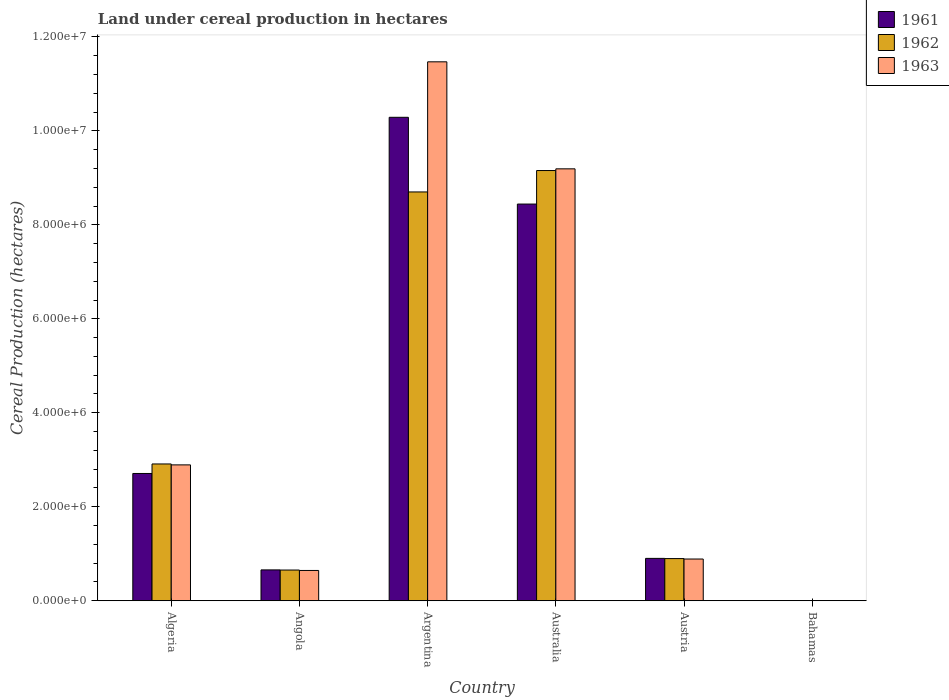How many groups of bars are there?
Offer a terse response. 6. How many bars are there on the 4th tick from the left?
Offer a very short reply. 3. What is the label of the 2nd group of bars from the left?
Ensure brevity in your answer.  Angola. In how many cases, is the number of bars for a given country not equal to the number of legend labels?
Give a very brief answer. 0. What is the land under cereal production in 1962 in Algeria?
Make the answer very short. 2.91e+06. Across all countries, what is the maximum land under cereal production in 1961?
Offer a very short reply. 1.03e+07. Across all countries, what is the minimum land under cereal production in 1963?
Provide a succinct answer. 240. In which country was the land under cereal production in 1961 minimum?
Your response must be concise. Bahamas. What is the total land under cereal production in 1963 in the graph?
Ensure brevity in your answer.  2.51e+07. What is the difference between the land under cereal production in 1963 in Angola and that in Argentina?
Ensure brevity in your answer.  -1.08e+07. What is the difference between the land under cereal production in 1961 in Algeria and the land under cereal production in 1962 in Argentina?
Make the answer very short. -5.99e+06. What is the average land under cereal production in 1961 per country?
Ensure brevity in your answer.  3.83e+06. What is the difference between the land under cereal production of/in 1962 and land under cereal production of/in 1961 in Argentina?
Your response must be concise. -1.59e+06. What is the ratio of the land under cereal production in 1962 in Argentina to that in Australia?
Offer a terse response. 0.95. What is the difference between the highest and the second highest land under cereal production in 1963?
Your response must be concise. 6.30e+06. What is the difference between the highest and the lowest land under cereal production in 1962?
Your response must be concise. 9.15e+06. Is the sum of the land under cereal production in 1962 in Algeria and Argentina greater than the maximum land under cereal production in 1963 across all countries?
Offer a very short reply. Yes. What does the 3rd bar from the left in Algeria represents?
Offer a very short reply. 1963. How many bars are there?
Give a very brief answer. 18. How many countries are there in the graph?
Give a very brief answer. 6. Does the graph contain grids?
Give a very brief answer. No. Where does the legend appear in the graph?
Ensure brevity in your answer.  Top right. How many legend labels are there?
Your answer should be compact. 3. What is the title of the graph?
Your response must be concise. Land under cereal production in hectares. What is the label or title of the X-axis?
Offer a very short reply. Country. What is the label or title of the Y-axis?
Your answer should be very brief. Cereal Production (hectares). What is the Cereal Production (hectares) in 1961 in Algeria?
Keep it short and to the point. 2.71e+06. What is the Cereal Production (hectares) of 1962 in Algeria?
Keep it short and to the point. 2.91e+06. What is the Cereal Production (hectares) in 1963 in Algeria?
Your response must be concise. 2.89e+06. What is the Cereal Production (hectares) in 1961 in Angola?
Your answer should be very brief. 6.57e+05. What is the Cereal Production (hectares) in 1962 in Angola?
Keep it short and to the point. 6.54e+05. What is the Cereal Production (hectares) of 1963 in Angola?
Your response must be concise. 6.45e+05. What is the Cereal Production (hectares) of 1961 in Argentina?
Provide a succinct answer. 1.03e+07. What is the Cereal Production (hectares) of 1962 in Argentina?
Give a very brief answer. 8.70e+06. What is the Cereal Production (hectares) in 1963 in Argentina?
Make the answer very short. 1.15e+07. What is the Cereal Production (hectares) of 1961 in Australia?
Give a very brief answer. 8.44e+06. What is the Cereal Production (hectares) in 1962 in Australia?
Keep it short and to the point. 9.15e+06. What is the Cereal Production (hectares) in 1963 in Australia?
Your answer should be compact. 9.19e+06. What is the Cereal Production (hectares) in 1961 in Austria?
Your response must be concise. 9.02e+05. What is the Cereal Production (hectares) of 1962 in Austria?
Give a very brief answer. 8.98e+05. What is the Cereal Production (hectares) in 1963 in Austria?
Keep it short and to the point. 8.88e+05. What is the Cereal Production (hectares) of 1961 in Bahamas?
Offer a very short reply. 150. What is the Cereal Production (hectares) of 1962 in Bahamas?
Provide a short and direct response. 180. What is the Cereal Production (hectares) in 1963 in Bahamas?
Your answer should be very brief. 240. Across all countries, what is the maximum Cereal Production (hectares) in 1961?
Offer a very short reply. 1.03e+07. Across all countries, what is the maximum Cereal Production (hectares) in 1962?
Your answer should be compact. 9.15e+06. Across all countries, what is the maximum Cereal Production (hectares) in 1963?
Give a very brief answer. 1.15e+07. Across all countries, what is the minimum Cereal Production (hectares) of 1961?
Offer a terse response. 150. Across all countries, what is the minimum Cereal Production (hectares) in 1962?
Offer a very short reply. 180. Across all countries, what is the minimum Cereal Production (hectares) of 1963?
Provide a succinct answer. 240. What is the total Cereal Production (hectares) in 1961 in the graph?
Ensure brevity in your answer.  2.30e+07. What is the total Cereal Production (hectares) of 1962 in the graph?
Offer a very short reply. 2.23e+07. What is the total Cereal Production (hectares) in 1963 in the graph?
Offer a very short reply. 2.51e+07. What is the difference between the Cereal Production (hectares) in 1961 in Algeria and that in Angola?
Provide a succinct answer. 2.05e+06. What is the difference between the Cereal Production (hectares) of 1962 in Algeria and that in Angola?
Your answer should be compact. 2.26e+06. What is the difference between the Cereal Production (hectares) in 1963 in Algeria and that in Angola?
Your answer should be compact. 2.25e+06. What is the difference between the Cereal Production (hectares) of 1961 in Algeria and that in Argentina?
Provide a succinct answer. -7.58e+06. What is the difference between the Cereal Production (hectares) of 1962 in Algeria and that in Argentina?
Your response must be concise. -5.79e+06. What is the difference between the Cereal Production (hectares) in 1963 in Algeria and that in Argentina?
Give a very brief answer. -8.58e+06. What is the difference between the Cereal Production (hectares) of 1961 in Algeria and that in Australia?
Provide a short and direct response. -5.73e+06. What is the difference between the Cereal Production (hectares) of 1962 in Algeria and that in Australia?
Keep it short and to the point. -6.24e+06. What is the difference between the Cereal Production (hectares) of 1963 in Algeria and that in Australia?
Your answer should be compact. -6.30e+06. What is the difference between the Cereal Production (hectares) in 1961 in Algeria and that in Austria?
Your answer should be very brief. 1.81e+06. What is the difference between the Cereal Production (hectares) in 1962 in Algeria and that in Austria?
Offer a terse response. 2.01e+06. What is the difference between the Cereal Production (hectares) of 1963 in Algeria and that in Austria?
Keep it short and to the point. 2.00e+06. What is the difference between the Cereal Production (hectares) in 1961 in Algeria and that in Bahamas?
Your response must be concise. 2.71e+06. What is the difference between the Cereal Production (hectares) of 1962 in Algeria and that in Bahamas?
Your response must be concise. 2.91e+06. What is the difference between the Cereal Production (hectares) of 1963 in Algeria and that in Bahamas?
Ensure brevity in your answer.  2.89e+06. What is the difference between the Cereal Production (hectares) in 1961 in Angola and that in Argentina?
Ensure brevity in your answer.  -9.63e+06. What is the difference between the Cereal Production (hectares) of 1962 in Angola and that in Argentina?
Your answer should be compact. -8.05e+06. What is the difference between the Cereal Production (hectares) of 1963 in Angola and that in Argentina?
Your answer should be very brief. -1.08e+07. What is the difference between the Cereal Production (hectares) of 1961 in Angola and that in Australia?
Your answer should be very brief. -7.78e+06. What is the difference between the Cereal Production (hectares) in 1962 in Angola and that in Australia?
Make the answer very short. -8.50e+06. What is the difference between the Cereal Production (hectares) in 1963 in Angola and that in Australia?
Your answer should be very brief. -8.55e+06. What is the difference between the Cereal Production (hectares) of 1961 in Angola and that in Austria?
Give a very brief answer. -2.45e+05. What is the difference between the Cereal Production (hectares) of 1962 in Angola and that in Austria?
Your response must be concise. -2.44e+05. What is the difference between the Cereal Production (hectares) in 1963 in Angola and that in Austria?
Your answer should be very brief. -2.43e+05. What is the difference between the Cereal Production (hectares) of 1961 in Angola and that in Bahamas?
Provide a short and direct response. 6.57e+05. What is the difference between the Cereal Production (hectares) of 1962 in Angola and that in Bahamas?
Your answer should be very brief. 6.54e+05. What is the difference between the Cereal Production (hectares) of 1963 in Angola and that in Bahamas?
Provide a succinct answer. 6.45e+05. What is the difference between the Cereal Production (hectares) in 1961 in Argentina and that in Australia?
Provide a short and direct response. 1.85e+06. What is the difference between the Cereal Production (hectares) in 1962 in Argentina and that in Australia?
Offer a terse response. -4.55e+05. What is the difference between the Cereal Production (hectares) of 1963 in Argentina and that in Australia?
Ensure brevity in your answer.  2.28e+06. What is the difference between the Cereal Production (hectares) in 1961 in Argentina and that in Austria?
Provide a succinct answer. 9.39e+06. What is the difference between the Cereal Production (hectares) in 1962 in Argentina and that in Austria?
Offer a very short reply. 7.80e+06. What is the difference between the Cereal Production (hectares) of 1963 in Argentina and that in Austria?
Offer a terse response. 1.06e+07. What is the difference between the Cereal Production (hectares) in 1961 in Argentina and that in Bahamas?
Provide a succinct answer. 1.03e+07. What is the difference between the Cereal Production (hectares) of 1962 in Argentina and that in Bahamas?
Your answer should be compact. 8.70e+06. What is the difference between the Cereal Production (hectares) of 1963 in Argentina and that in Bahamas?
Give a very brief answer. 1.15e+07. What is the difference between the Cereal Production (hectares) of 1961 in Australia and that in Austria?
Your answer should be very brief. 7.54e+06. What is the difference between the Cereal Production (hectares) of 1962 in Australia and that in Austria?
Your answer should be compact. 8.26e+06. What is the difference between the Cereal Production (hectares) of 1963 in Australia and that in Austria?
Provide a short and direct response. 8.30e+06. What is the difference between the Cereal Production (hectares) of 1961 in Australia and that in Bahamas?
Keep it short and to the point. 8.44e+06. What is the difference between the Cereal Production (hectares) in 1962 in Australia and that in Bahamas?
Offer a terse response. 9.15e+06. What is the difference between the Cereal Production (hectares) of 1963 in Australia and that in Bahamas?
Your response must be concise. 9.19e+06. What is the difference between the Cereal Production (hectares) of 1961 in Austria and that in Bahamas?
Keep it short and to the point. 9.02e+05. What is the difference between the Cereal Production (hectares) in 1962 in Austria and that in Bahamas?
Your response must be concise. 8.98e+05. What is the difference between the Cereal Production (hectares) in 1963 in Austria and that in Bahamas?
Make the answer very short. 8.88e+05. What is the difference between the Cereal Production (hectares) of 1961 in Algeria and the Cereal Production (hectares) of 1962 in Angola?
Make the answer very short. 2.05e+06. What is the difference between the Cereal Production (hectares) of 1961 in Algeria and the Cereal Production (hectares) of 1963 in Angola?
Ensure brevity in your answer.  2.06e+06. What is the difference between the Cereal Production (hectares) of 1962 in Algeria and the Cereal Production (hectares) of 1963 in Angola?
Your answer should be compact. 2.27e+06. What is the difference between the Cereal Production (hectares) in 1961 in Algeria and the Cereal Production (hectares) in 1962 in Argentina?
Your answer should be compact. -5.99e+06. What is the difference between the Cereal Production (hectares) in 1961 in Algeria and the Cereal Production (hectares) in 1963 in Argentina?
Give a very brief answer. -8.76e+06. What is the difference between the Cereal Production (hectares) of 1962 in Algeria and the Cereal Production (hectares) of 1963 in Argentina?
Your answer should be very brief. -8.56e+06. What is the difference between the Cereal Production (hectares) in 1961 in Algeria and the Cereal Production (hectares) in 1962 in Australia?
Give a very brief answer. -6.45e+06. What is the difference between the Cereal Production (hectares) in 1961 in Algeria and the Cereal Production (hectares) in 1963 in Australia?
Your answer should be very brief. -6.48e+06. What is the difference between the Cereal Production (hectares) of 1962 in Algeria and the Cereal Production (hectares) of 1963 in Australia?
Keep it short and to the point. -6.28e+06. What is the difference between the Cereal Production (hectares) of 1961 in Algeria and the Cereal Production (hectares) of 1962 in Austria?
Offer a very short reply. 1.81e+06. What is the difference between the Cereal Production (hectares) in 1961 in Algeria and the Cereal Production (hectares) in 1963 in Austria?
Offer a terse response. 1.82e+06. What is the difference between the Cereal Production (hectares) in 1962 in Algeria and the Cereal Production (hectares) in 1963 in Austria?
Your answer should be very brief. 2.02e+06. What is the difference between the Cereal Production (hectares) of 1961 in Algeria and the Cereal Production (hectares) of 1962 in Bahamas?
Your answer should be compact. 2.71e+06. What is the difference between the Cereal Production (hectares) of 1961 in Algeria and the Cereal Production (hectares) of 1963 in Bahamas?
Give a very brief answer. 2.71e+06. What is the difference between the Cereal Production (hectares) in 1962 in Algeria and the Cereal Production (hectares) in 1963 in Bahamas?
Ensure brevity in your answer.  2.91e+06. What is the difference between the Cereal Production (hectares) of 1961 in Angola and the Cereal Production (hectares) of 1962 in Argentina?
Your answer should be compact. -8.04e+06. What is the difference between the Cereal Production (hectares) of 1961 in Angola and the Cereal Production (hectares) of 1963 in Argentina?
Keep it short and to the point. -1.08e+07. What is the difference between the Cereal Production (hectares) in 1962 in Angola and the Cereal Production (hectares) in 1963 in Argentina?
Your response must be concise. -1.08e+07. What is the difference between the Cereal Production (hectares) of 1961 in Angola and the Cereal Production (hectares) of 1962 in Australia?
Your answer should be compact. -8.50e+06. What is the difference between the Cereal Production (hectares) of 1961 in Angola and the Cereal Production (hectares) of 1963 in Australia?
Provide a short and direct response. -8.53e+06. What is the difference between the Cereal Production (hectares) of 1962 in Angola and the Cereal Production (hectares) of 1963 in Australia?
Your response must be concise. -8.54e+06. What is the difference between the Cereal Production (hectares) of 1961 in Angola and the Cereal Production (hectares) of 1962 in Austria?
Your answer should be very brief. -2.41e+05. What is the difference between the Cereal Production (hectares) in 1961 in Angola and the Cereal Production (hectares) in 1963 in Austria?
Your response must be concise. -2.31e+05. What is the difference between the Cereal Production (hectares) of 1962 in Angola and the Cereal Production (hectares) of 1963 in Austria?
Provide a succinct answer. -2.34e+05. What is the difference between the Cereal Production (hectares) in 1961 in Angola and the Cereal Production (hectares) in 1962 in Bahamas?
Keep it short and to the point. 6.57e+05. What is the difference between the Cereal Production (hectares) of 1961 in Angola and the Cereal Production (hectares) of 1963 in Bahamas?
Provide a succinct answer. 6.57e+05. What is the difference between the Cereal Production (hectares) in 1962 in Angola and the Cereal Production (hectares) in 1963 in Bahamas?
Provide a short and direct response. 6.54e+05. What is the difference between the Cereal Production (hectares) of 1961 in Argentina and the Cereal Production (hectares) of 1962 in Australia?
Offer a terse response. 1.13e+06. What is the difference between the Cereal Production (hectares) of 1961 in Argentina and the Cereal Production (hectares) of 1963 in Australia?
Your response must be concise. 1.10e+06. What is the difference between the Cereal Production (hectares) in 1962 in Argentina and the Cereal Production (hectares) in 1963 in Australia?
Ensure brevity in your answer.  -4.92e+05. What is the difference between the Cereal Production (hectares) of 1961 in Argentina and the Cereal Production (hectares) of 1962 in Austria?
Give a very brief answer. 9.39e+06. What is the difference between the Cereal Production (hectares) in 1961 in Argentina and the Cereal Production (hectares) in 1963 in Austria?
Offer a terse response. 9.40e+06. What is the difference between the Cereal Production (hectares) of 1962 in Argentina and the Cereal Production (hectares) of 1963 in Austria?
Make the answer very short. 7.81e+06. What is the difference between the Cereal Production (hectares) of 1961 in Argentina and the Cereal Production (hectares) of 1962 in Bahamas?
Your answer should be very brief. 1.03e+07. What is the difference between the Cereal Production (hectares) of 1961 in Argentina and the Cereal Production (hectares) of 1963 in Bahamas?
Provide a succinct answer. 1.03e+07. What is the difference between the Cereal Production (hectares) in 1962 in Argentina and the Cereal Production (hectares) in 1963 in Bahamas?
Offer a very short reply. 8.70e+06. What is the difference between the Cereal Production (hectares) of 1961 in Australia and the Cereal Production (hectares) of 1962 in Austria?
Provide a succinct answer. 7.54e+06. What is the difference between the Cereal Production (hectares) in 1961 in Australia and the Cereal Production (hectares) in 1963 in Austria?
Your answer should be very brief. 7.55e+06. What is the difference between the Cereal Production (hectares) of 1962 in Australia and the Cereal Production (hectares) of 1963 in Austria?
Ensure brevity in your answer.  8.27e+06. What is the difference between the Cereal Production (hectares) in 1961 in Australia and the Cereal Production (hectares) in 1962 in Bahamas?
Make the answer very short. 8.44e+06. What is the difference between the Cereal Production (hectares) of 1961 in Australia and the Cereal Production (hectares) of 1963 in Bahamas?
Provide a succinct answer. 8.44e+06. What is the difference between the Cereal Production (hectares) of 1962 in Australia and the Cereal Production (hectares) of 1963 in Bahamas?
Make the answer very short. 9.15e+06. What is the difference between the Cereal Production (hectares) of 1961 in Austria and the Cereal Production (hectares) of 1962 in Bahamas?
Ensure brevity in your answer.  9.02e+05. What is the difference between the Cereal Production (hectares) of 1961 in Austria and the Cereal Production (hectares) of 1963 in Bahamas?
Offer a very short reply. 9.02e+05. What is the difference between the Cereal Production (hectares) of 1962 in Austria and the Cereal Production (hectares) of 1963 in Bahamas?
Your answer should be very brief. 8.98e+05. What is the average Cereal Production (hectares) of 1961 per country?
Provide a succinct answer. 3.83e+06. What is the average Cereal Production (hectares) in 1962 per country?
Give a very brief answer. 3.72e+06. What is the average Cereal Production (hectares) of 1963 per country?
Make the answer very short. 4.18e+06. What is the difference between the Cereal Production (hectares) of 1961 and Cereal Production (hectares) of 1962 in Algeria?
Ensure brevity in your answer.  -2.03e+05. What is the difference between the Cereal Production (hectares) of 1961 and Cereal Production (hectares) of 1963 in Algeria?
Your answer should be very brief. -1.83e+05. What is the difference between the Cereal Production (hectares) of 1962 and Cereal Production (hectares) of 1963 in Algeria?
Provide a short and direct response. 1.99e+04. What is the difference between the Cereal Production (hectares) in 1961 and Cereal Production (hectares) in 1962 in Angola?
Your response must be concise. 3000. What is the difference between the Cereal Production (hectares) of 1961 and Cereal Production (hectares) of 1963 in Angola?
Ensure brevity in your answer.  1.20e+04. What is the difference between the Cereal Production (hectares) of 1962 and Cereal Production (hectares) of 1963 in Angola?
Ensure brevity in your answer.  9000. What is the difference between the Cereal Production (hectares) in 1961 and Cereal Production (hectares) in 1962 in Argentina?
Your answer should be very brief. 1.59e+06. What is the difference between the Cereal Production (hectares) of 1961 and Cereal Production (hectares) of 1963 in Argentina?
Your response must be concise. -1.18e+06. What is the difference between the Cereal Production (hectares) in 1962 and Cereal Production (hectares) in 1963 in Argentina?
Ensure brevity in your answer.  -2.77e+06. What is the difference between the Cereal Production (hectares) of 1961 and Cereal Production (hectares) of 1962 in Australia?
Your answer should be compact. -7.13e+05. What is the difference between the Cereal Production (hectares) of 1961 and Cereal Production (hectares) of 1963 in Australia?
Offer a very short reply. -7.50e+05. What is the difference between the Cereal Production (hectares) of 1962 and Cereal Production (hectares) of 1963 in Australia?
Provide a succinct answer. -3.66e+04. What is the difference between the Cereal Production (hectares) of 1961 and Cereal Production (hectares) of 1962 in Austria?
Provide a succinct answer. 4295. What is the difference between the Cereal Production (hectares) of 1961 and Cereal Production (hectares) of 1963 in Austria?
Make the answer very short. 1.38e+04. What is the difference between the Cereal Production (hectares) in 1962 and Cereal Production (hectares) in 1963 in Austria?
Keep it short and to the point. 9525. What is the difference between the Cereal Production (hectares) of 1961 and Cereal Production (hectares) of 1963 in Bahamas?
Your response must be concise. -90. What is the difference between the Cereal Production (hectares) of 1962 and Cereal Production (hectares) of 1963 in Bahamas?
Keep it short and to the point. -60. What is the ratio of the Cereal Production (hectares) of 1961 in Algeria to that in Angola?
Provide a short and direct response. 4.12. What is the ratio of the Cereal Production (hectares) in 1962 in Algeria to that in Angola?
Give a very brief answer. 4.45. What is the ratio of the Cereal Production (hectares) of 1963 in Algeria to that in Angola?
Your answer should be compact. 4.48. What is the ratio of the Cereal Production (hectares) in 1961 in Algeria to that in Argentina?
Provide a succinct answer. 0.26. What is the ratio of the Cereal Production (hectares) in 1962 in Algeria to that in Argentina?
Your answer should be compact. 0.33. What is the ratio of the Cereal Production (hectares) in 1963 in Algeria to that in Argentina?
Your response must be concise. 0.25. What is the ratio of the Cereal Production (hectares) of 1961 in Algeria to that in Australia?
Keep it short and to the point. 0.32. What is the ratio of the Cereal Production (hectares) in 1962 in Algeria to that in Australia?
Offer a very short reply. 0.32. What is the ratio of the Cereal Production (hectares) in 1963 in Algeria to that in Australia?
Ensure brevity in your answer.  0.31. What is the ratio of the Cereal Production (hectares) of 1961 in Algeria to that in Austria?
Keep it short and to the point. 3. What is the ratio of the Cereal Production (hectares) of 1962 in Algeria to that in Austria?
Provide a short and direct response. 3.24. What is the ratio of the Cereal Production (hectares) in 1963 in Algeria to that in Austria?
Offer a very short reply. 3.26. What is the ratio of the Cereal Production (hectares) in 1961 in Algeria to that in Bahamas?
Provide a succinct answer. 1.81e+04. What is the ratio of the Cereal Production (hectares) in 1962 in Algeria to that in Bahamas?
Offer a terse response. 1.62e+04. What is the ratio of the Cereal Production (hectares) of 1963 in Algeria to that in Bahamas?
Provide a succinct answer. 1.20e+04. What is the ratio of the Cereal Production (hectares) of 1961 in Angola to that in Argentina?
Your answer should be compact. 0.06. What is the ratio of the Cereal Production (hectares) of 1962 in Angola to that in Argentina?
Your answer should be very brief. 0.08. What is the ratio of the Cereal Production (hectares) of 1963 in Angola to that in Argentina?
Keep it short and to the point. 0.06. What is the ratio of the Cereal Production (hectares) of 1961 in Angola to that in Australia?
Offer a terse response. 0.08. What is the ratio of the Cereal Production (hectares) of 1962 in Angola to that in Australia?
Provide a succinct answer. 0.07. What is the ratio of the Cereal Production (hectares) of 1963 in Angola to that in Australia?
Your answer should be compact. 0.07. What is the ratio of the Cereal Production (hectares) of 1961 in Angola to that in Austria?
Provide a short and direct response. 0.73. What is the ratio of the Cereal Production (hectares) of 1962 in Angola to that in Austria?
Provide a short and direct response. 0.73. What is the ratio of the Cereal Production (hectares) in 1963 in Angola to that in Austria?
Make the answer very short. 0.73. What is the ratio of the Cereal Production (hectares) in 1961 in Angola to that in Bahamas?
Offer a very short reply. 4380. What is the ratio of the Cereal Production (hectares) of 1962 in Angola to that in Bahamas?
Your answer should be compact. 3633.33. What is the ratio of the Cereal Production (hectares) in 1963 in Angola to that in Bahamas?
Make the answer very short. 2687.5. What is the ratio of the Cereal Production (hectares) in 1961 in Argentina to that in Australia?
Provide a succinct answer. 1.22. What is the ratio of the Cereal Production (hectares) in 1962 in Argentina to that in Australia?
Offer a terse response. 0.95. What is the ratio of the Cereal Production (hectares) in 1963 in Argentina to that in Australia?
Keep it short and to the point. 1.25. What is the ratio of the Cereal Production (hectares) of 1961 in Argentina to that in Austria?
Offer a terse response. 11.4. What is the ratio of the Cereal Production (hectares) in 1962 in Argentina to that in Austria?
Provide a succinct answer. 9.69. What is the ratio of the Cereal Production (hectares) in 1963 in Argentina to that in Austria?
Your answer should be compact. 12.91. What is the ratio of the Cereal Production (hectares) of 1961 in Argentina to that in Bahamas?
Keep it short and to the point. 6.86e+04. What is the ratio of the Cereal Production (hectares) of 1962 in Argentina to that in Bahamas?
Provide a short and direct response. 4.83e+04. What is the ratio of the Cereal Production (hectares) in 1963 in Argentina to that in Bahamas?
Offer a very short reply. 4.78e+04. What is the ratio of the Cereal Production (hectares) in 1961 in Australia to that in Austria?
Provide a succinct answer. 9.36. What is the ratio of the Cereal Production (hectares) in 1962 in Australia to that in Austria?
Your answer should be compact. 10.2. What is the ratio of the Cereal Production (hectares) of 1963 in Australia to that in Austria?
Your response must be concise. 10.35. What is the ratio of the Cereal Production (hectares) in 1961 in Australia to that in Bahamas?
Keep it short and to the point. 5.63e+04. What is the ratio of the Cereal Production (hectares) in 1962 in Australia to that in Bahamas?
Make the answer very short. 5.09e+04. What is the ratio of the Cereal Production (hectares) of 1963 in Australia to that in Bahamas?
Keep it short and to the point. 3.83e+04. What is the ratio of the Cereal Production (hectares) in 1961 in Austria to that in Bahamas?
Offer a very short reply. 6013.93. What is the ratio of the Cereal Production (hectares) of 1962 in Austria to that in Bahamas?
Keep it short and to the point. 4987.74. What is the ratio of the Cereal Production (hectares) in 1963 in Austria to that in Bahamas?
Provide a short and direct response. 3701.12. What is the difference between the highest and the second highest Cereal Production (hectares) of 1961?
Make the answer very short. 1.85e+06. What is the difference between the highest and the second highest Cereal Production (hectares) of 1962?
Keep it short and to the point. 4.55e+05. What is the difference between the highest and the second highest Cereal Production (hectares) of 1963?
Give a very brief answer. 2.28e+06. What is the difference between the highest and the lowest Cereal Production (hectares) of 1961?
Make the answer very short. 1.03e+07. What is the difference between the highest and the lowest Cereal Production (hectares) of 1962?
Ensure brevity in your answer.  9.15e+06. What is the difference between the highest and the lowest Cereal Production (hectares) in 1963?
Ensure brevity in your answer.  1.15e+07. 